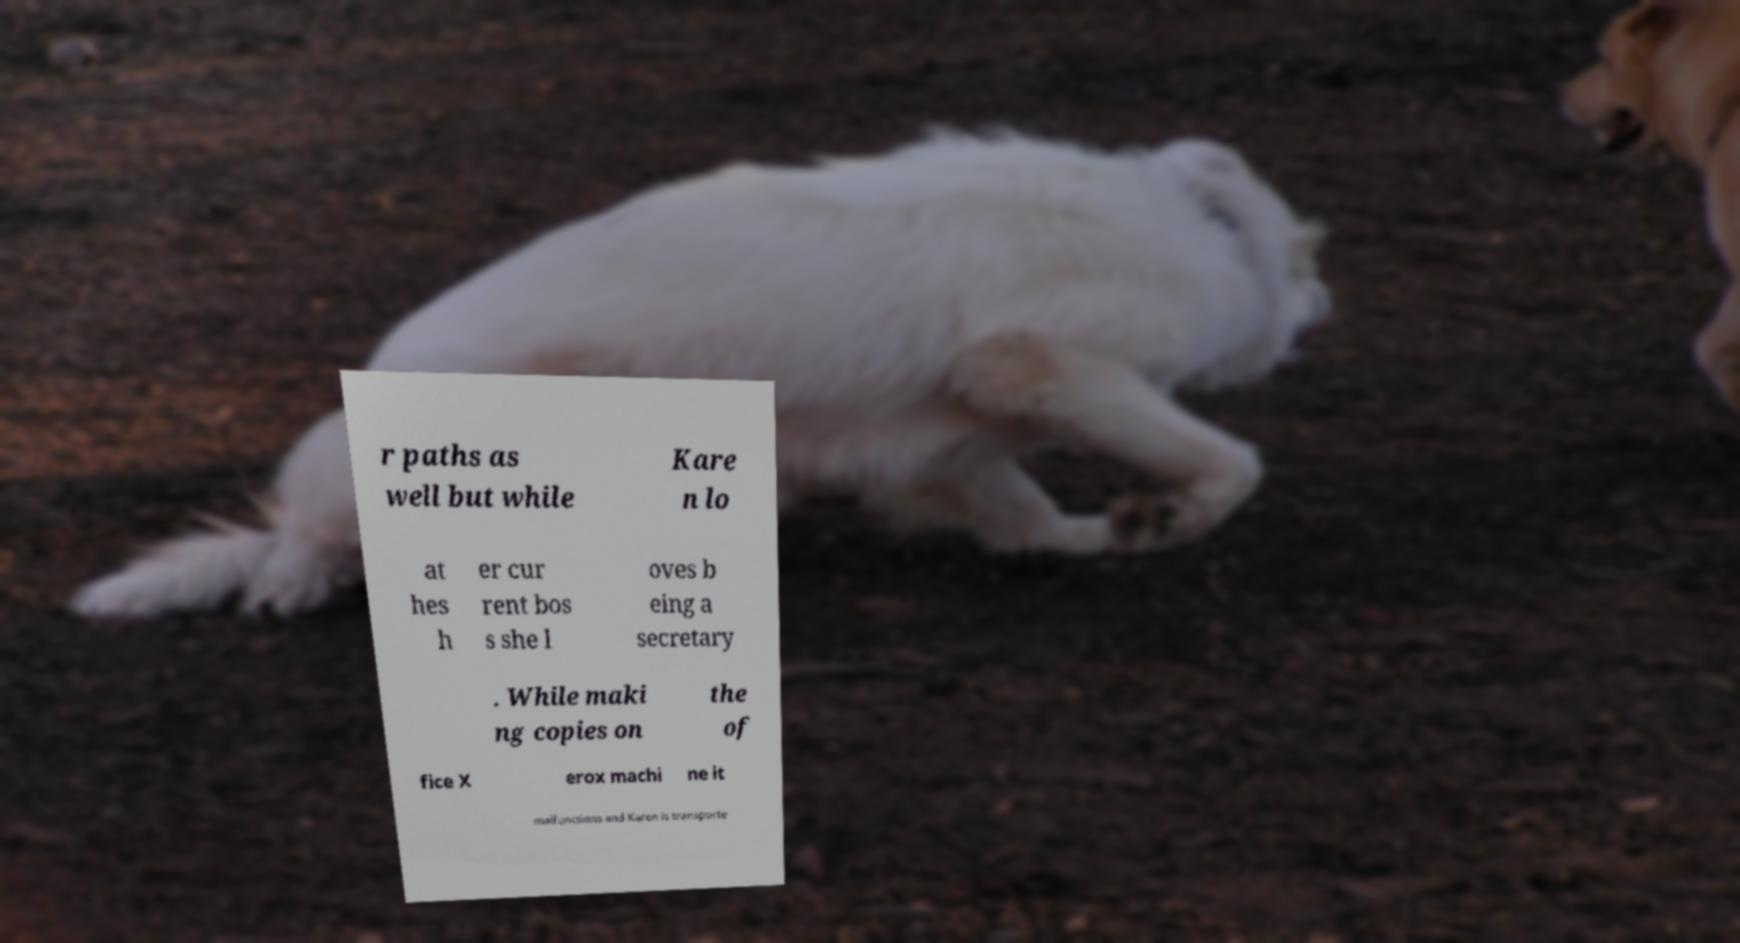Could you extract and type out the text from this image? r paths as well but while Kare n lo at hes h er cur rent bos s she l oves b eing a secretary . While maki ng copies on the of fice X erox machi ne it malfunctions and Karen is transporte 